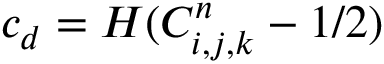Convert formula to latex. <formula><loc_0><loc_0><loc_500><loc_500>c _ { d } = H ( C _ { i , j , k } ^ { n } - 1 / 2 )</formula> 